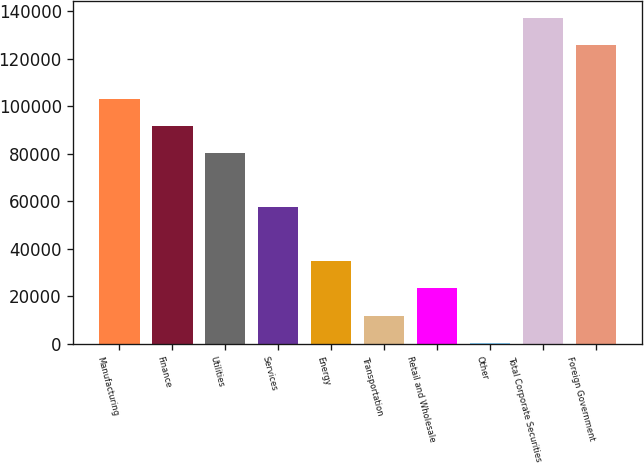<chart> <loc_0><loc_0><loc_500><loc_500><bar_chart><fcel>Manufacturing<fcel>Finance<fcel>Utilities<fcel>Services<fcel>Energy<fcel>Transportation<fcel>Retail and Wholesale<fcel>Other<fcel>Total Corporate Securities<fcel>Foreign Government<nl><fcel>103174<fcel>91770.4<fcel>80367.1<fcel>57560.5<fcel>34753.9<fcel>11947.3<fcel>23350.6<fcel>544<fcel>137384<fcel>125980<nl></chart> 